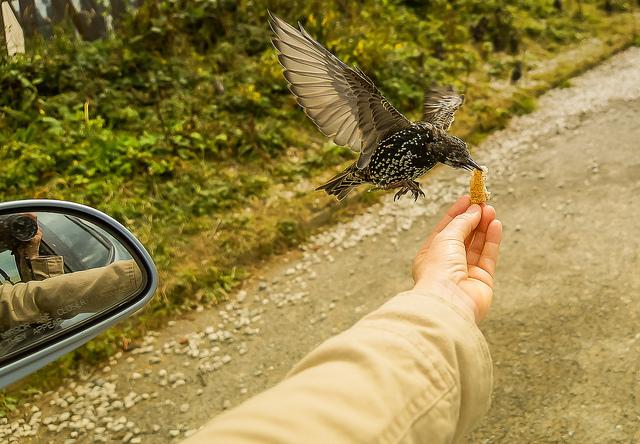Is this the average bird diet?
Quick response, please. No. What is portrayed in the mirror?
Concise answer only. Camera. Who is being fed?
Answer briefly. Bird. 